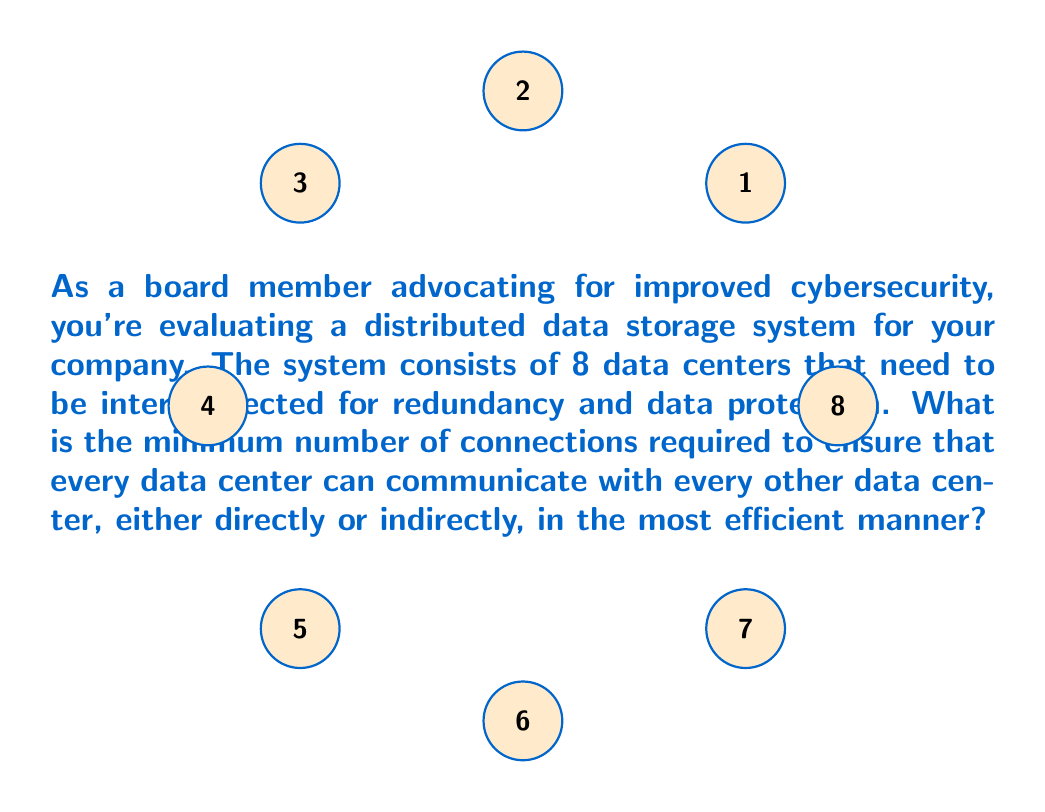Solve this math problem. To solve this problem, we need to understand the concept of a minimum spanning tree in graph theory. In a distributed system, we want to ensure full connectivity with the least number of connections, which is exactly what a minimum spanning tree provides.

Let's approach this step-by-step:

1) First, we recognize that we have 8 data centers, which will be the vertices in our graph.

2) In a fully connected graph with $n$ vertices, the number of edges would be $\frac{n(n-1)}{2}$. In this case, that would be $\frac{8(8-1)}{2} = 28$ connections. However, this is more than we need for full connectivity.

3) The minimum number of edges needed to connect $n$ vertices in a tree structure (which ensures connectivity with no redundant paths) is always $n-1$.

4) Therefore, the minimum number of connections needed is:

   $$\text{Minimum connections} = n - 1 = 8 - 1 = 7$$

5) This solution creates a tree-like structure where every data center is connected to the network, and there is exactly one path between any two data centers, ensuring efficient communication without redundancy.

6) It's worth noting that while this is the minimum number of connections for full connectivity, in real-world cybersecurity applications, some level of redundancy might be desirable for fault tolerance. However, the question asks for the minimum number of connections for full connectivity, which is achieved with 7 connections.
Answer: 7 connections 